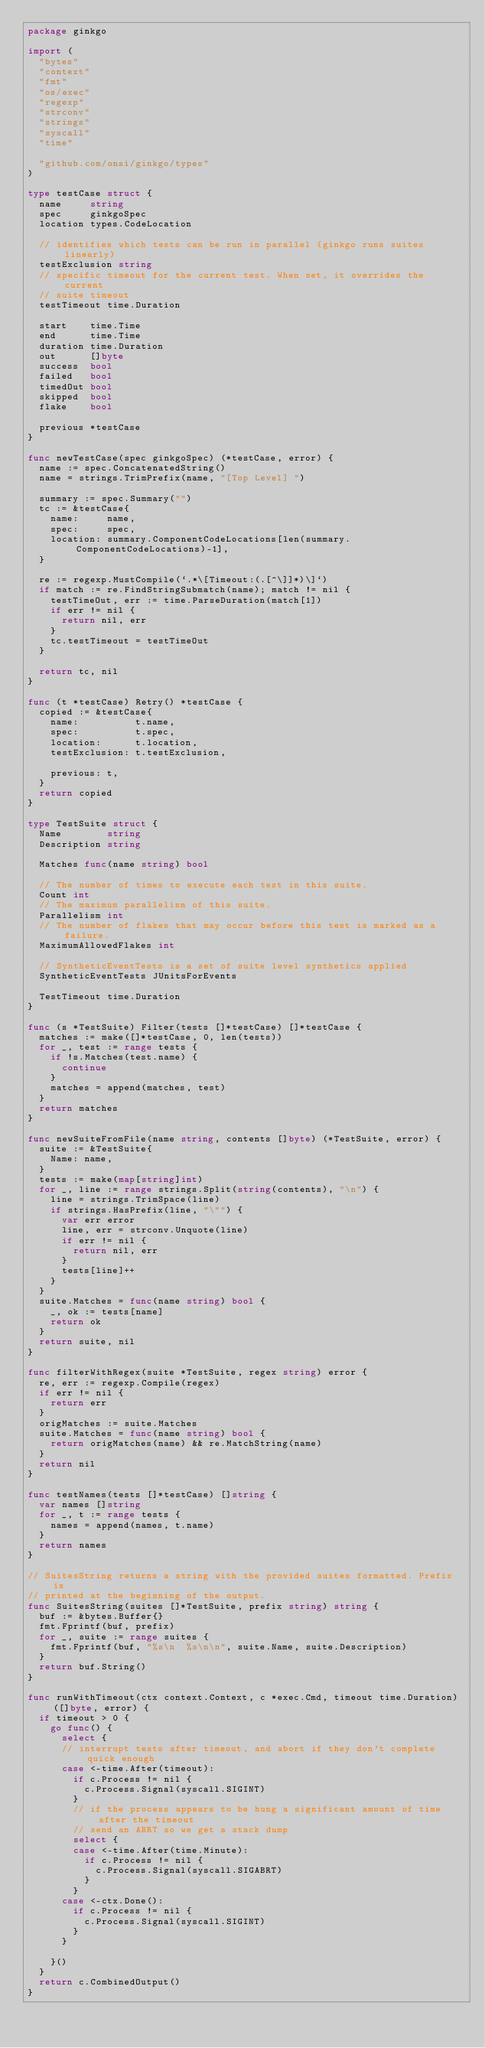<code> <loc_0><loc_0><loc_500><loc_500><_Go_>package ginkgo

import (
	"bytes"
	"context"
	"fmt"
	"os/exec"
	"regexp"
	"strconv"
	"strings"
	"syscall"
	"time"

	"github.com/onsi/ginkgo/types"
)

type testCase struct {
	name     string
	spec     ginkgoSpec
	location types.CodeLocation

	// identifies which tests can be run in parallel (ginkgo runs suites linearly)
	testExclusion string
	// specific timeout for the current test. When set, it overrides the current
	// suite timeout
	testTimeout time.Duration

	start    time.Time
	end      time.Time
	duration time.Duration
	out      []byte
	success  bool
	failed   bool
	timedOut bool
	skipped  bool
	flake    bool

	previous *testCase
}

func newTestCase(spec ginkgoSpec) (*testCase, error) {
	name := spec.ConcatenatedString()
	name = strings.TrimPrefix(name, "[Top Level] ")

	summary := spec.Summary("")
	tc := &testCase{
		name:     name,
		spec:     spec,
		location: summary.ComponentCodeLocations[len(summary.ComponentCodeLocations)-1],
	}

	re := regexp.MustCompile(`.*\[Timeout:(.[^\]]*)\]`)
	if match := re.FindStringSubmatch(name); match != nil {
		testTimeOut, err := time.ParseDuration(match[1])
		if err != nil {
			return nil, err
		}
		tc.testTimeout = testTimeOut
	}

	return tc, nil
}

func (t *testCase) Retry() *testCase {
	copied := &testCase{
		name:          t.name,
		spec:          t.spec,
		location:      t.location,
		testExclusion: t.testExclusion,

		previous: t,
	}
	return copied
}

type TestSuite struct {
	Name        string
	Description string

	Matches func(name string) bool

	// The number of times to execute each test in this suite.
	Count int
	// The maximum parallelism of this suite.
	Parallelism int
	// The number of flakes that may occur before this test is marked as a failure.
	MaximumAllowedFlakes int

	// SyntheticEventTests is a set of suite level synthetics applied
	SyntheticEventTests JUnitsForEvents

	TestTimeout time.Duration
}

func (s *TestSuite) Filter(tests []*testCase) []*testCase {
	matches := make([]*testCase, 0, len(tests))
	for _, test := range tests {
		if !s.Matches(test.name) {
			continue
		}
		matches = append(matches, test)
	}
	return matches
}

func newSuiteFromFile(name string, contents []byte) (*TestSuite, error) {
	suite := &TestSuite{
		Name: name,
	}
	tests := make(map[string]int)
	for _, line := range strings.Split(string(contents), "\n") {
		line = strings.TrimSpace(line)
		if strings.HasPrefix(line, "\"") {
			var err error
			line, err = strconv.Unquote(line)
			if err != nil {
				return nil, err
			}
			tests[line]++
		}
	}
	suite.Matches = func(name string) bool {
		_, ok := tests[name]
		return ok
	}
	return suite, nil
}

func filterWithRegex(suite *TestSuite, regex string) error {
	re, err := regexp.Compile(regex)
	if err != nil {
		return err
	}
	origMatches := suite.Matches
	suite.Matches = func(name string) bool {
		return origMatches(name) && re.MatchString(name)
	}
	return nil
}

func testNames(tests []*testCase) []string {
	var names []string
	for _, t := range tests {
		names = append(names, t.name)
	}
	return names
}

// SuitesString returns a string with the provided suites formatted. Prefix is
// printed at the beginning of the output.
func SuitesString(suites []*TestSuite, prefix string) string {
	buf := &bytes.Buffer{}
	fmt.Fprintf(buf, prefix)
	for _, suite := range suites {
		fmt.Fprintf(buf, "%s\n  %s\n\n", suite.Name, suite.Description)
	}
	return buf.String()
}

func runWithTimeout(ctx context.Context, c *exec.Cmd, timeout time.Duration) ([]byte, error) {
	if timeout > 0 {
		go func() {
			select {
			// interrupt tests after timeout, and abort if they don't complete quick enough
			case <-time.After(timeout):
				if c.Process != nil {
					c.Process.Signal(syscall.SIGINT)
				}
				// if the process appears to be hung a significant amount of time after the timeout
				// send an ABRT so we get a stack dump
				select {
				case <-time.After(time.Minute):
					if c.Process != nil {
						c.Process.Signal(syscall.SIGABRT)
					}
				}
			case <-ctx.Done():
				if c.Process != nil {
					c.Process.Signal(syscall.SIGINT)
				}
			}

		}()
	}
	return c.CombinedOutput()
}
</code> 